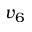Convert formula to latex. <formula><loc_0><loc_0><loc_500><loc_500>v _ { 6 }</formula> 